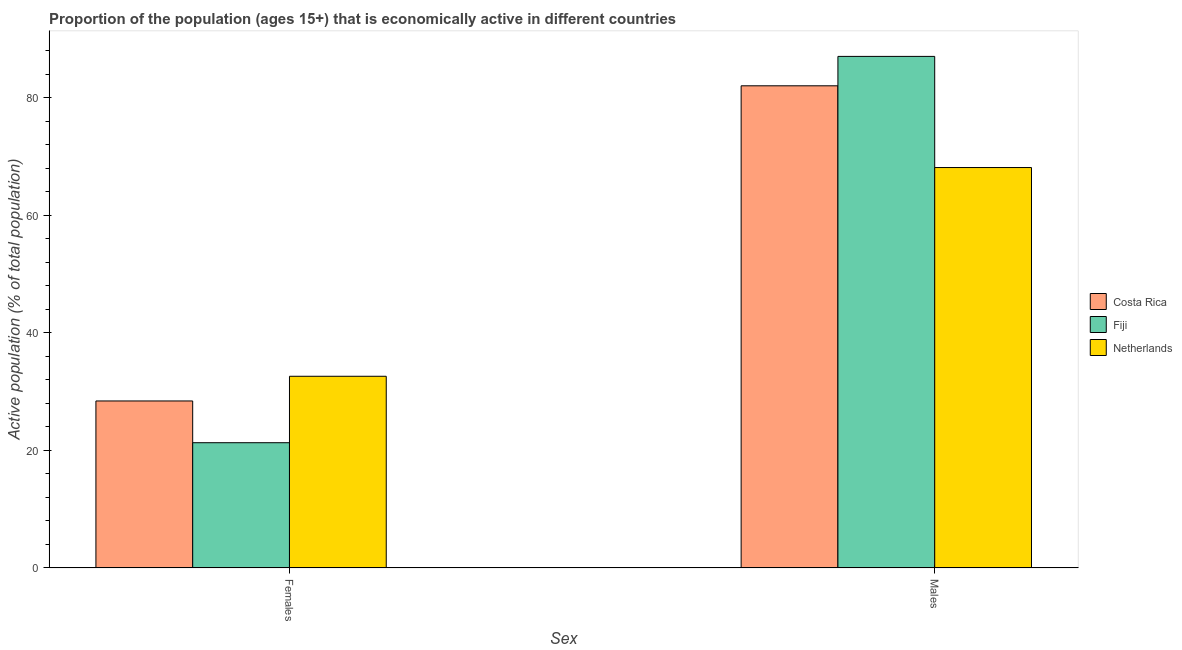What is the label of the 1st group of bars from the left?
Provide a short and direct response. Females. Across all countries, what is the maximum percentage of economically active female population?
Ensure brevity in your answer.  32.6. Across all countries, what is the minimum percentage of economically active male population?
Provide a short and direct response. 68.1. In which country was the percentage of economically active male population maximum?
Your answer should be compact. Fiji. In which country was the percentage of economically active male population minimum?
Offer a very short reply. Netherlands. What is the total percentage of economically active female population in the graph?
Ensure brevity in your answer.  82.3. What is the difference between the percentage of economically active female population in Netherlands and that in Costa Rica?
Offer a very short reply. 4.2. What is the difference between the percentage of economically active male population in Fiji and the percentage of economically active female population in Costa Rica?
Ensure brevity in your answer.  58.6. What is the average percentage of economically active male population per country?
Provide a succinct answer. 79.03. What is the difference between the percentage of economically active male population and percentage of economically active female population in Costa Rica?
Offer a very short reply. 53.6. In how many countries, is the percentage of economically active male population greater than 84 %?
Offer a very short reply. 1. What is the ratio of the percentage of economically active male population in Netherlands to that in Costa Rica?
Provide a succinct answer. 0.83. Is the percentage of economically active female population in Netherlands less than that in Costa Rica?
Offer a very short reply. No. In how many countries, is the percentage of economically active male population greater than the average percentage of economically active male population taken over all countries?
Ensure brevity in your answer.  2. What does the 2nd bar from the left in Males represents?
Keep it short and to the point. Fiji. How many bars are there?
Keep it short and to the point. 6. Are all the bars in the graph horizontal?
Provide a short and direct response. No. How many countries are there in the graph?
Make the answer very short. 3. What is the difference between two consecutive major ticks on the Y-axis?
Offer a terse response. 20. Are the values on the major ticks of Y-axis written in scientific E-notation?
Provide a short and direct response. No. Does the graph contain any zero values?
Your answer should be compact. No. Does the graph contain grids?
Keep it short and to the point. No. Where does the legend appear in the graph?
Give a very brief answer. Center right. What is the title of the graph?
Keep it short and to the point. Proportion of the population (ages 15+) that is economically active in different countries. Does "Italy" appear as one of the legend labels in the graph?
Offer a very short reply. No. What is the label or title of the X-axis?
Keep it short and to the point. Sex. What is the label or title of the Y-axis?
Ensure brevity in your answer.  Active population (% of total population). What is the Active population (% of total population) in Costa Rica in Females?
Your answer should be compact. 28.4. What is the Active population (% of total population) of Fiji in Females?
Ensure brevity in your answer.  21.3. What is the Active population (% of total population) in Netherlands in Females?
Ensure brevity in your answer.  32.6. What is the Active population (% of total population) of Fiji in Males?
Your answer should be compact. 87. What is the Active population (% of total population) in Netherlands in Males?
Your answer should be compact. 68.1. Across all Sex, what is the maximum Active population (% of total population) of Costa Rica?
Your answer should be compact. 82. Across all Sex, what is the maximum Active population (% of total population) of Fiji?
Your answer should be compact. 87. Across all Sex, what is the maximum Active population (% of total population) of Netherlands?
Your answer should be very brief. 68.1. Across all Sex, what is the minimum Active population (% of total population) of Costa Rica?
Ensure brevity in your answer.  28.4. Across all Sex, what is the minimum Active population (% of total population) in Fiji?
Ensure brevity in your answer.  21.3. Across all Sex, what is the minimum Active population (% of total population) in Netherlands?
Your answer should be very brief. 32.6. What is the total Active population (% of total population) in Costa Rica in the graph?
Your answer should be compact. 110.4. What is the total Active population (% of total population) of Fiji in the graph?
Give a very brief answer. 108.3. What is the total Active population (% of total population) in Netherlands in the graph?
Keep it short and to the point. 100.7. What is the difference between the Active population (% of total population) in Costa Rica in Females and that in Males?
Make the answer very short. -53.6. What is the difference between the Active population (% of total population) of Fiji in Females and that in Males?
Ensure brevity in your answer.  -65.7. What is the difference between the Active population (% of total population) in Netherlands in Females and that in Males?
Your answer should be very brief. -35.5. What is the difference between the Active population (% of total population) of Costa Rica in Females and the Active population (% of total population) of Fiji in Males?
Your response must be concise. -58.6. What is the difference between the Active population (% of total population) of Costa Rica in Females and the Active population (% of total population) of Netherlands in Males?
Make the answer very short. -39.7. What is the difference between the Active population (% of total population) of Fiji in Females and the Active population (% of total population) of Netherlands in Males?
Provide a short and direct response. -46.8. What is the average Active population (% of total population) of Costa Rica per Sex?
Your response must be concise. 55.2. What is the average Active population (% of total population) in Fiji per Sex?
Provide a short and direct response. 54.15. What is the average Active population (% of total population) of Netherlands per Sex?
Give a very brief answer. 50.35. What is the difference between the Active population (% of total population) of Costa Rica and Active population (% of total population) of Fiji in Females?
Your response must be concise. 7.1. What is the difference between the Active population (% of total population) of Costa Rica and Active population (% of total population) of Netherlands in Females?
Your response must be concise. -4.2. What is the difference between the Active population (% of total population) in Costa Rica and Active population (% of total population) in Fiji in Males?
Ensure brevity in your answer.  -5. What is the difference between the Active population (% of total population) in Fiji and Active population (% of total population) in Netherlands in Males?
Your response must be concise. 18.9. What is the ratio of the Active population (% of total population) in Costa Rica in Females to that in Males?
Your response must be concise. 0.35. What is the ratio of the Active population (% of total population) in Fiji in Females to that in Males?
Keep it short and to the point. 0.24. What is the ratio of the Active population (% of total population) of Netherlands in Females to that in Males?
Your response must be concise. 0.48. What is the difference between the highest and the second highest Active population (% of total population) of Costa Rica?
Give a very brief answer. 53.6. What is the difference between the highest and the second highest Active population (% of total population) in Fiji?
Provide a succinct answer. 65.7. What is the difference between the highest and the second highest Active population (% of total population) in Netherlands?
Your response must be concise. 35.5. What is the difference between the highest and the lowest Active population (% of total population) in Costa Rica?
Provide a succinct answer. 53.6. What is the difference between the highest and the lowest Active population (% of total population) in Fiji?
Your answer should be very brief. 65.7. What is the difference between the highest and the lowest Active population (% of total population) of Netherlands?
Your answer should be compact. 35.5. 